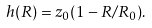Convert formula to latex. <formula><loc_0><loc_0><loc_500><loc_500>h ( R ) = z _ { 0 } ( 1 - R / R _ { 0 } ) .</formula> 